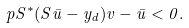<formula> <loc_0><loc_0><loc_500><loc_500>p { S ^ { * } ( S \bar { u } - y _ { d } ) } { v - \bar { u } } < 0 .</formula> 